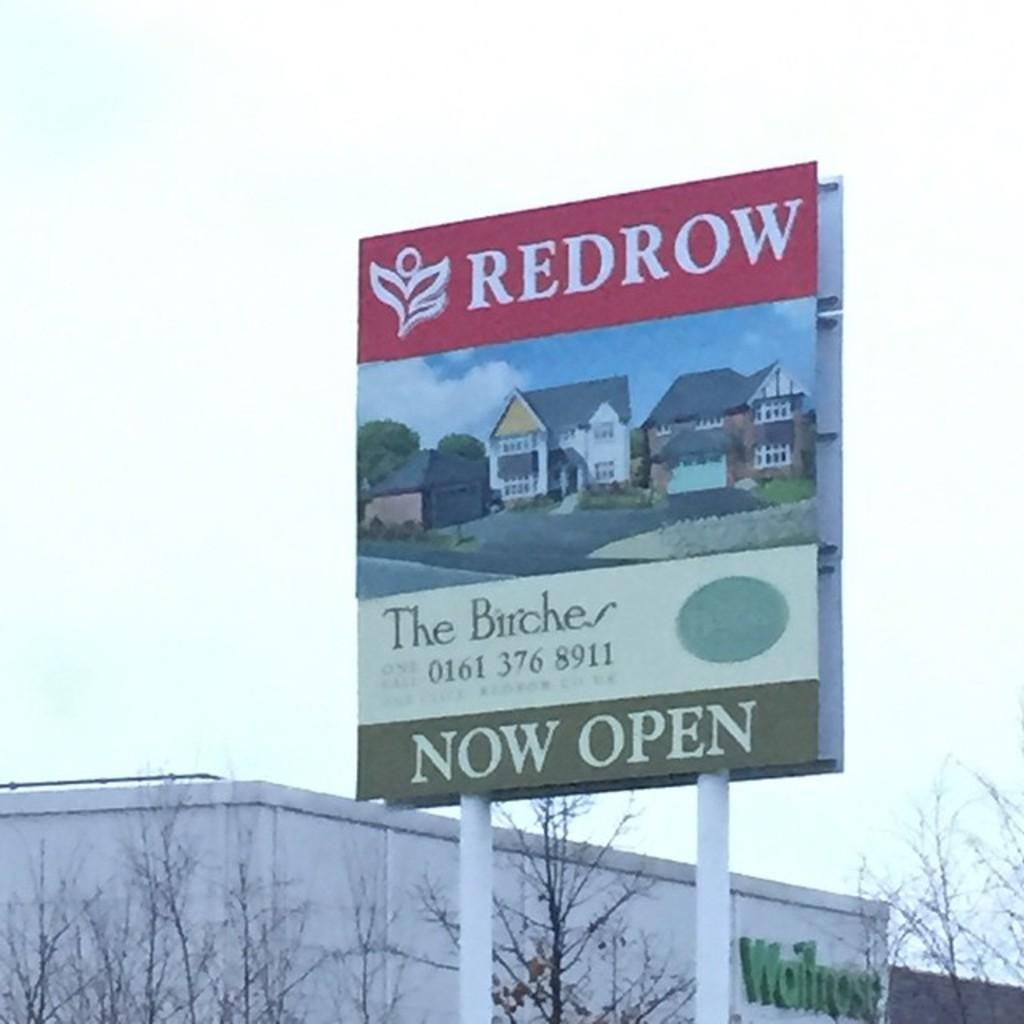<image>
Render a clear and concise summary of the photo. A tall sign near a building with the word redrow written on it. 